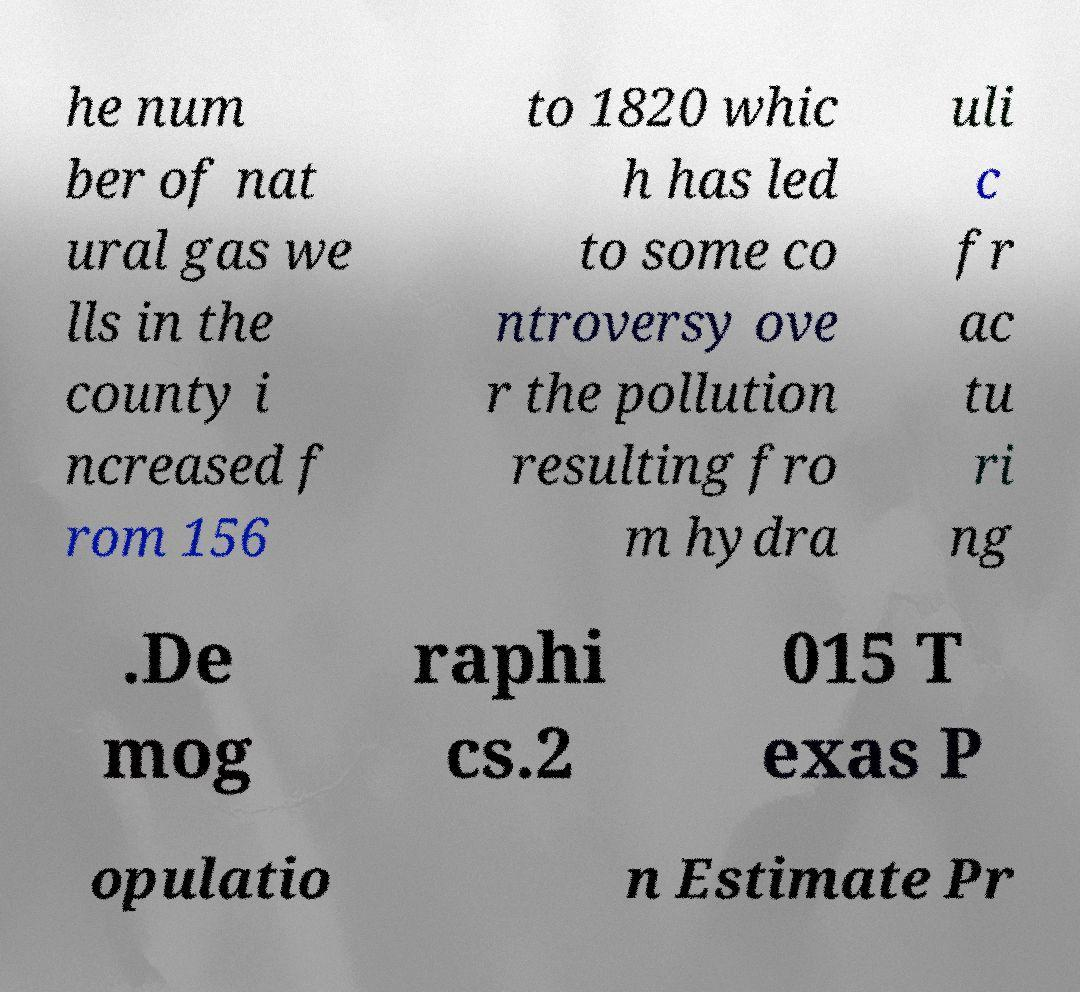Please identify and transcribe the text found in this image. he num ber of nat ural gas we lls in the county i ncreased f rom 156 to 1820 whic h has led to some co ntroversy ove r the pollution resulting fro m hydra uli c fr ac tu ri ng .De mog raphi cs.2 015 T exas P opulatio n Estimate Pr 